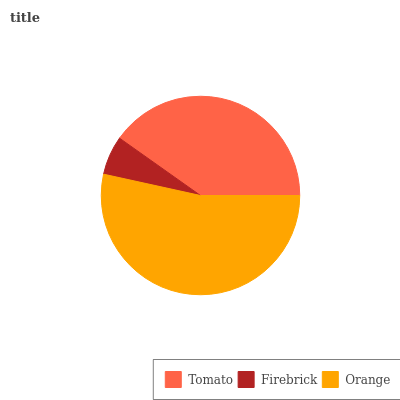Is Firebrick the minimum?
Answer yes or no. Yes. Is Orange the maximum?
Answer yes or no. Yes. Is Orange the minimum?
Answer yes or no. No. Is Firebrick the maximum?
Answer yes or no. No. Is Orange greater than Firebrick?
Answer yes or no. Yes. Is Firebrick less than Orange?
Answer yes or no. Yes. Is Firebrick greater than Orange?
Answer yes or no. No. Is Orange less than Firebrick?
Answer yes or no. No. Is Tomato the high median?
Answer yes or no. Yes. Is Tomato the low median?
Answer yes or no. Yes. Is Orange the high median?
Answer yes or no. No. Is Orange the low median?
Answer yes or no. No. 